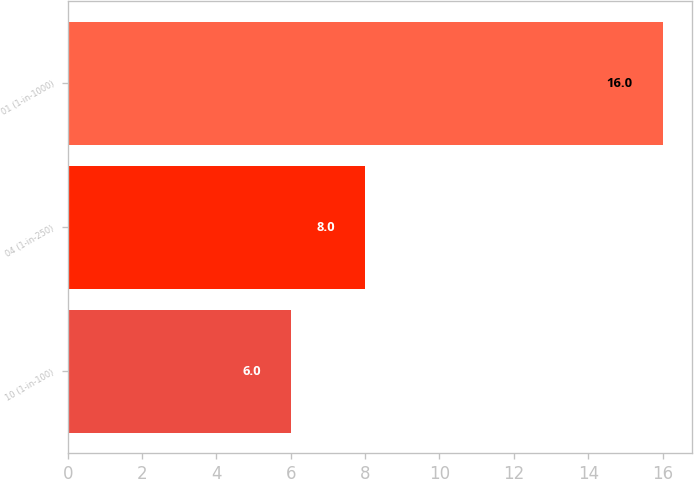<chart> <loc_0><loc_0><loc_500><loc_500><bar_chart><fcel>10 (1-in-100)<fcel>04 (1-in-250)<fcel>01 (1-in-1000)<nl><fcel>6<fcel>8<fcel>16<nl></chart> 